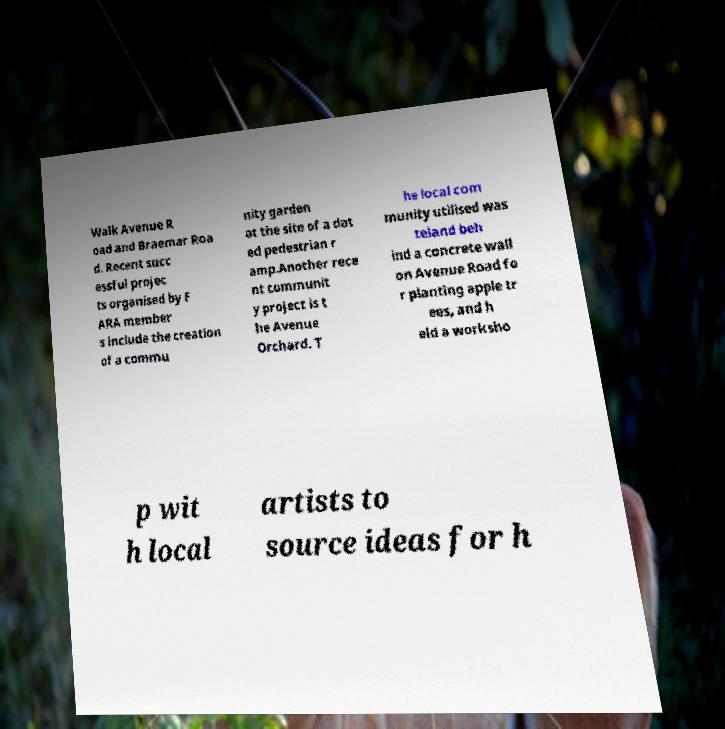Please identify and transcribe the text found in this image. Walk Avenue R oad and Braemar Roa d. Recent succ essful projec ts organised by F ARA member s include the creation of a commu nity garden at the site of a dat ed pedestrian r amp.Another rece nt communit y project is t he Avenue Orchard. T he local com munity utilised was teland beh ind a concrete wall on Avenue Road fo r planting apple tr ees, and h eld a worksho p wit h local artists to source ideas for h 